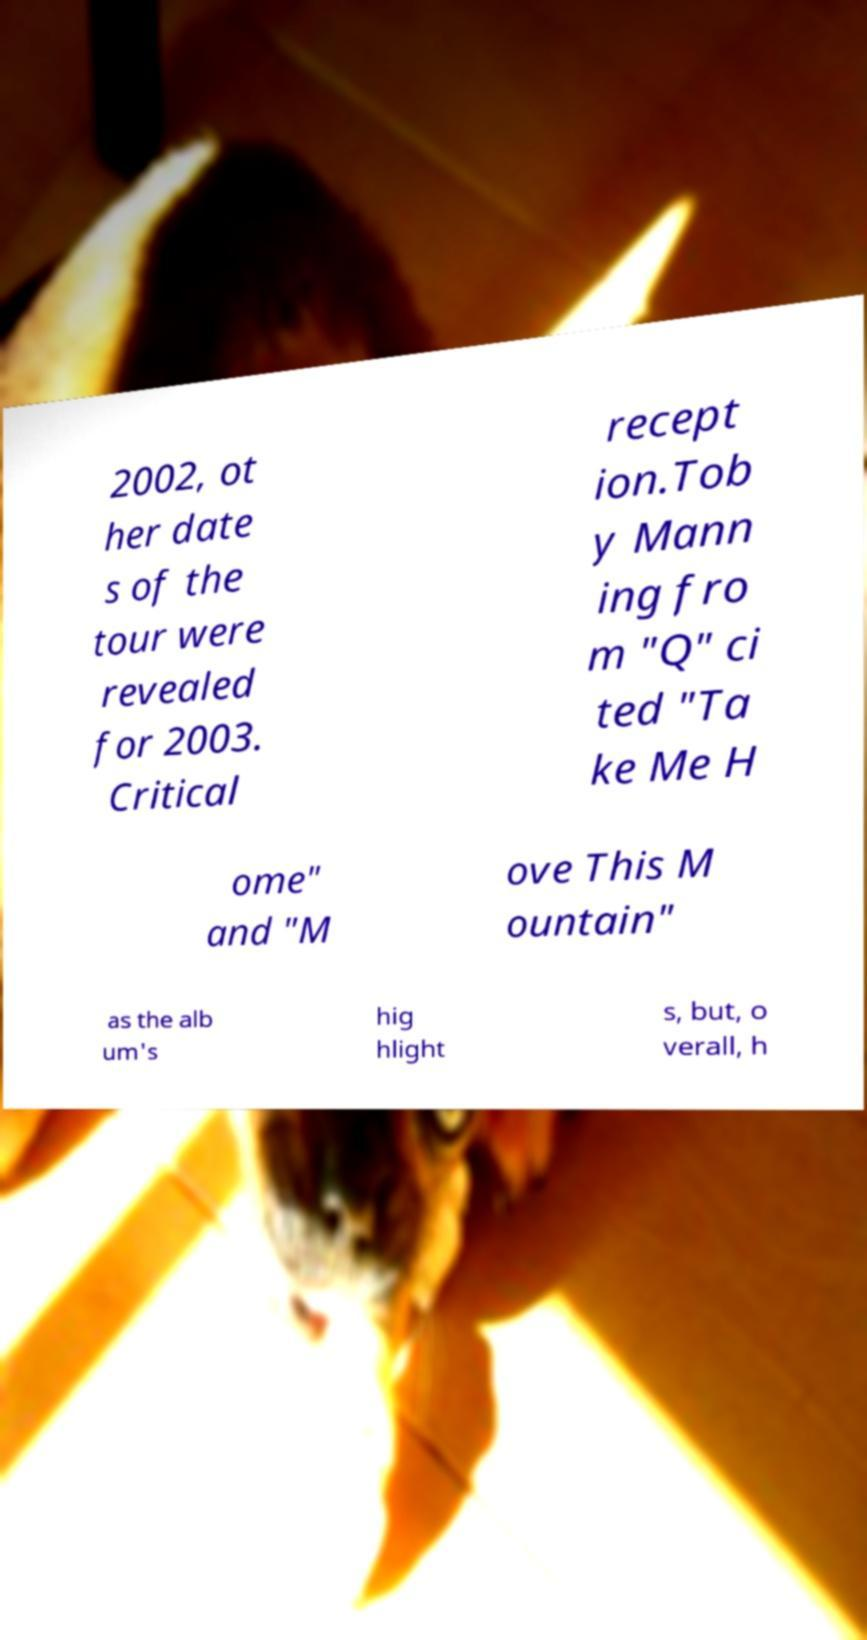Can you read and provide the text displayed in the image?This photo seems to have some interesting text. Can you extract and type it out for me? 2002, ot her date s of the tour were revealed for 2003. Critical recept ion.Tob y Mann ing fro m "Q" ci ted "Ta ke Me H ome" and "M ove This M ountain" as the alb um's hig hlight s, but, o verall, h 